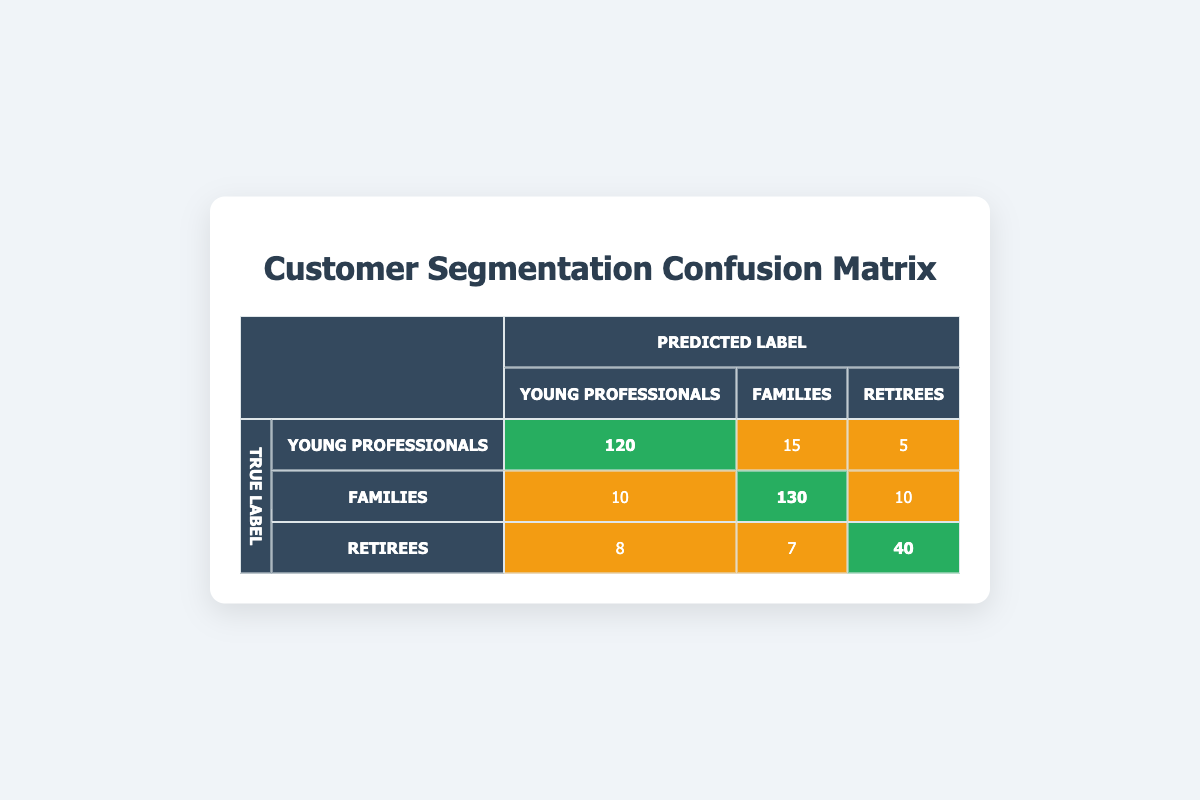What is the count of correctly predicted Young Professionals? The count of correctly predicted Young Professionals is indicated in the diagonal of the matrix, which shows the true label matched with the predicted label. In this case, it is 120.
Answer: 120 How many Families were incorrectly classified as Young Professionals? The count of Families that were incorrectly classified is found in the cell under the "Young Professionals" row and the "Families" column, which shows 10.
Answer: 10 What is the total number of Retirees represented in the table? To find the total number of Retirees, we add up the values from the Retirees row: 8 (predicted as Young Professionals) + 7 (predicted as Families) + 40 (predicted as Retirees) = 55.
Answer: 55 Is it true that more Families were correctly identified than incorrectly classified? Looking at the diagonal for Families, the value is 130, and for incorrectly classified Families (Young Professionals to Families counts), the total is 10 (10 predicted as Young Professionals) + 10 (10 predicted as Retirees) = 20, making it true that 130 > 20.
Answer: Yes What is the overall accuracy of the segmentation for each group? To calculate overall accuracy, we find the total correct predictions (120 + 130 + 40 = 290), and the total predictions made (290 + 15 + 5 + 10 + 10 + 10 + 8 + 7 = 385). Accuracy is 290/385 = 0.754, or roughly 75.4%.
Answer: 75.4% What is the count of all misclassifications for Young Professionals? To find misclassifications, we look at the Young Professionals row and total up the counts that are not on the diagonal: 15 (predicted as Families) + 5 (predicted as Retirees) = 20.
Answer: 20 What percentage of the total predictions were correctly classified as Retirees? The count of correctly classified Retirees is 40. The total predictions made are 385. The percentage is (40/385) * 100 ≈ 10.39%.
Answer: 10.39% How many more Young Professionals were predicted than Retirees? First, we find the predicted Young Professionals count: 120 (true Young Professionals) + 10 (mistakenly classified from Families) + 8 (mistakenly classified from Retirees) = 138. The predicted Retirees count is 40. Thus, 138 - 40 = 98.
Answer: 98 